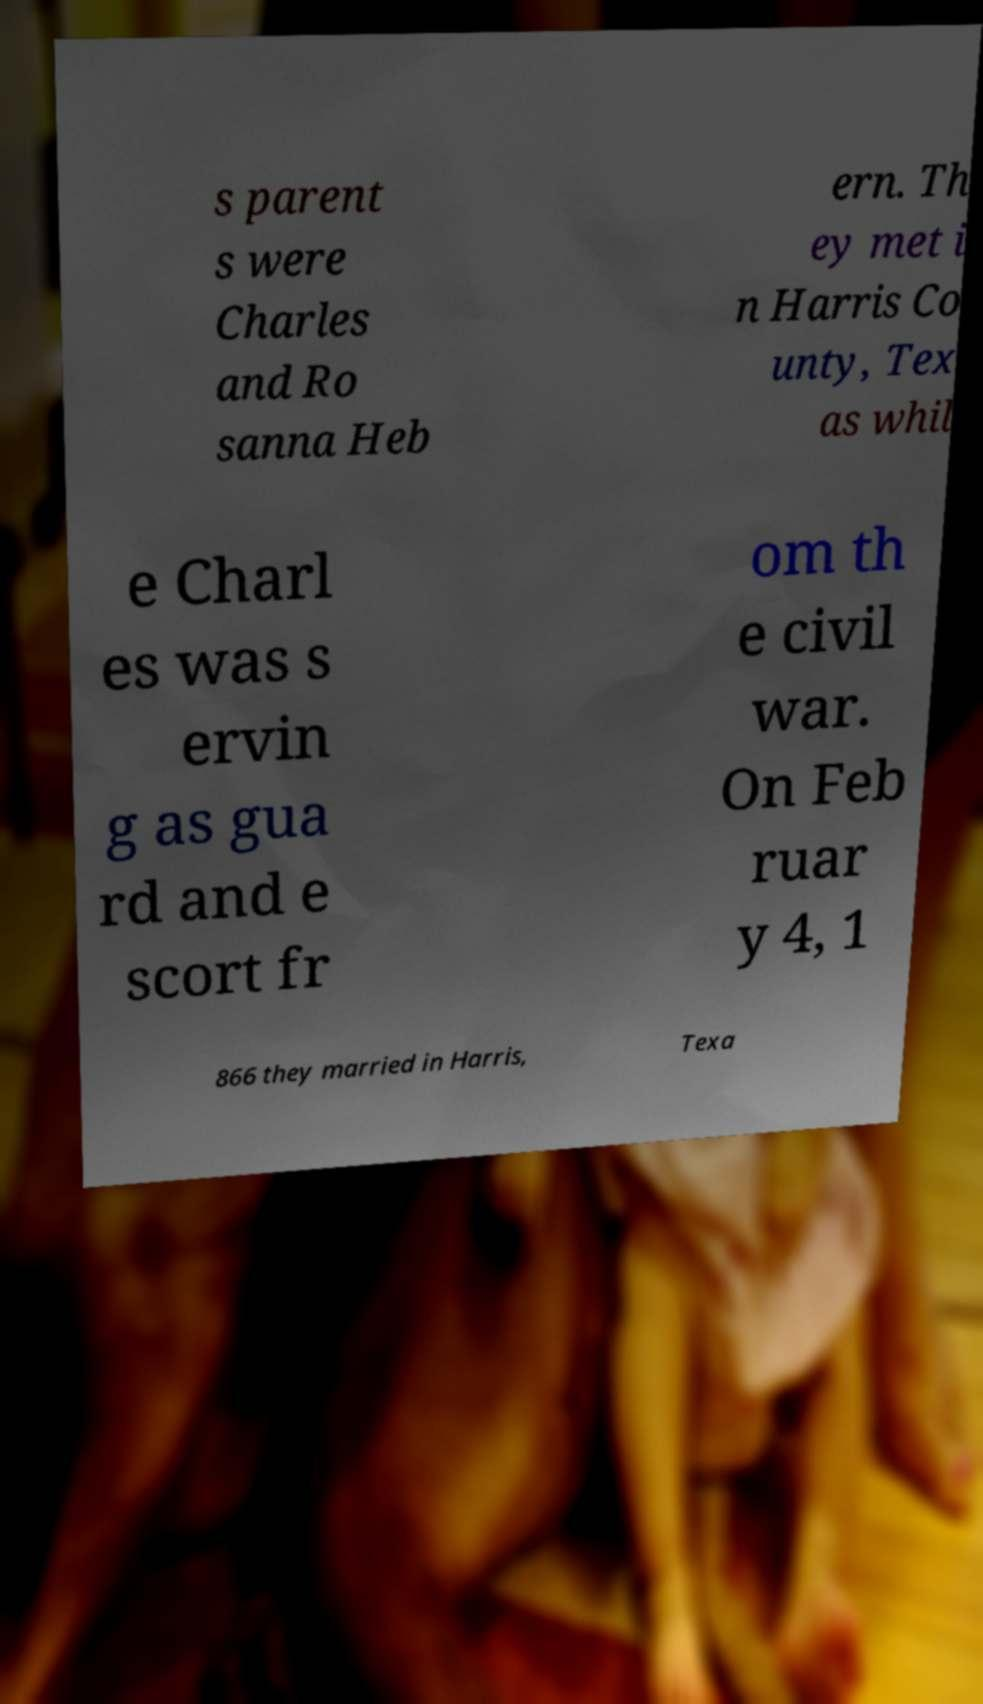Can you accurately transcribe the text from the provided image for me? s parent s were Charles and Ro sanna Heb ern. Th ey met i n Harris Co unty, Tex as whil e Charl es was s ervin g as gua rd and e scort fr om th e civil war. On Feb ruar y 4, 1 866 they married in Harris, Texa 